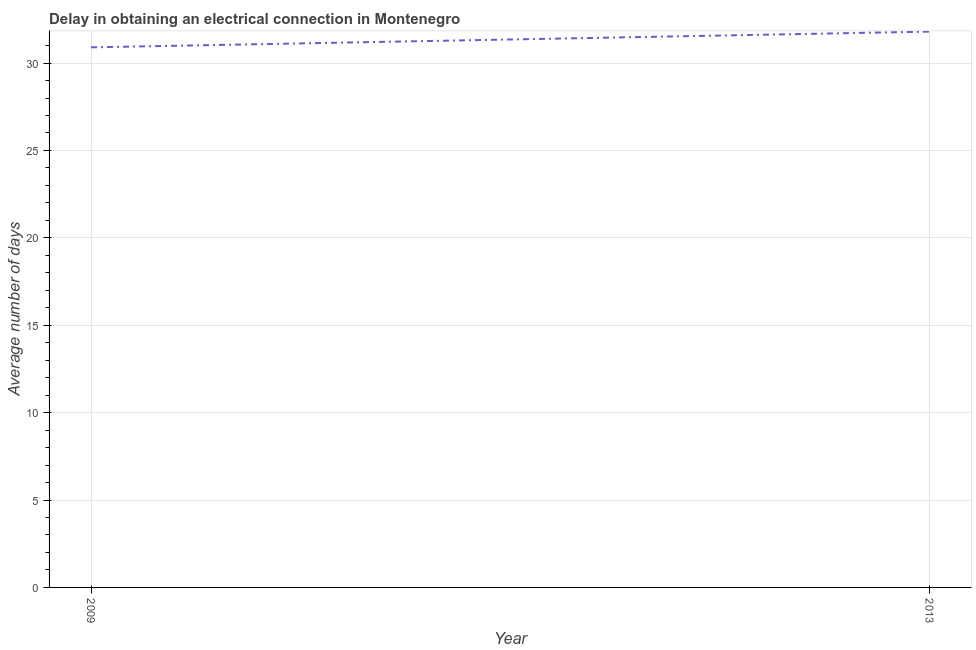What is the dalay in electrical connection in 2009?
Offer a terse response. 30.9. Across all years, what is the maximum dalay in electrical connection?
Ensure brevity in your answer.  31.8. Across all years, what is the minimum dalay in electrical connection?
Keep it short and to the point. 30.9. In which year was the dalay in electrical connection maximum?
Keep it short and to the point. 2013. What is the sum of the dalay in electrical connection?
Keep it short and to the point. 62.7. What is the difference between the dalay in electrical connection in 2009 and 2013?
Your answer should be compact. -0.9. What is the average dalay in electrical connection per year?
Give a very brief answer. 31.35. What is the median dalay in electrical connection?
Give a very brief answer. 31.35. What is the ratio of the dalay in electrical connection in 2009 to that in 2013?
Provide a short and direct response. 0.97. Is the dalay in electrical connection in 2009 less than that in 2013?
Your response must be concise. Yes. In how many years, is the dalay in electrical connection greater than the average dalay in electrical connection taken over all years?
Make the answer very short. 1. How many lines are there?
Offer a terse response. 1. How many years are there in the graph?
Your response must be concise. 2. What is the difference between two consecutive major ticks on the Y-axis?
Provide a short and direct response. 5. What is the title of the graph?
Give a very brief answer. Delay in obtaining an electrical connection in Montenegro. What is the label or title of the X-axis?
Offer a terse response. Year. What is the label or title of the Y-axis?
Give a very brief answer. Average number of days. What is the Average number of days in 2009?
Provide a succinct answer. 30.9. What is the Average number of days in 2013?
Your answer should be compact. 31.8. What is the difference between the Average number of days in 2009 and 2013?
Make the answer very short. -0.9. 